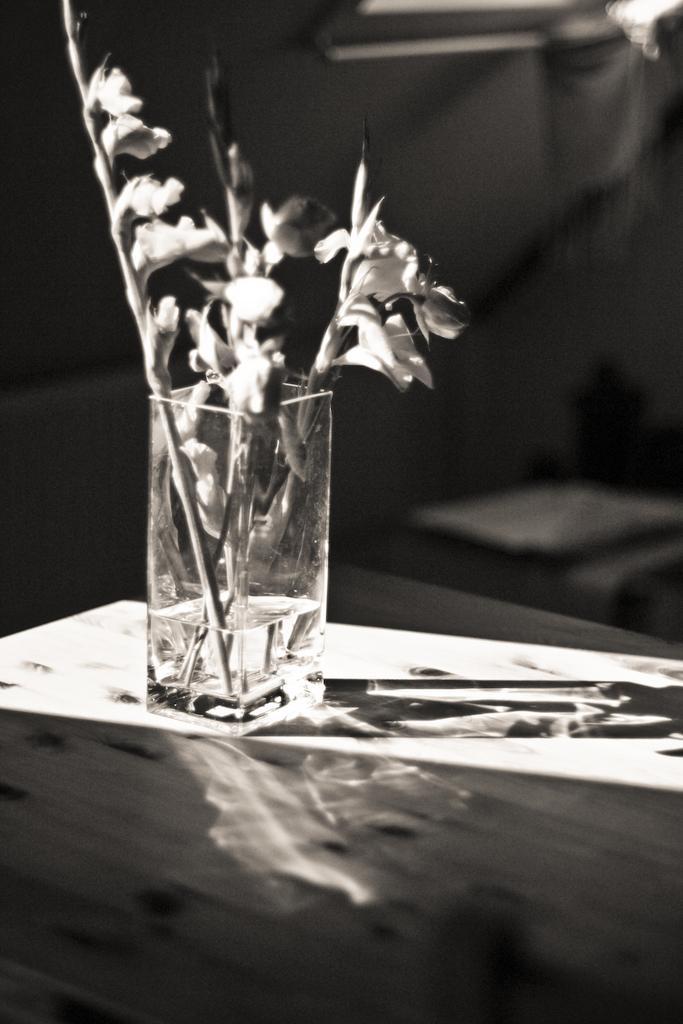Can you describe this image briefly? This is a black and white pic. There are flowers and less than half water in a glass on a platform. In the background there are objects. 